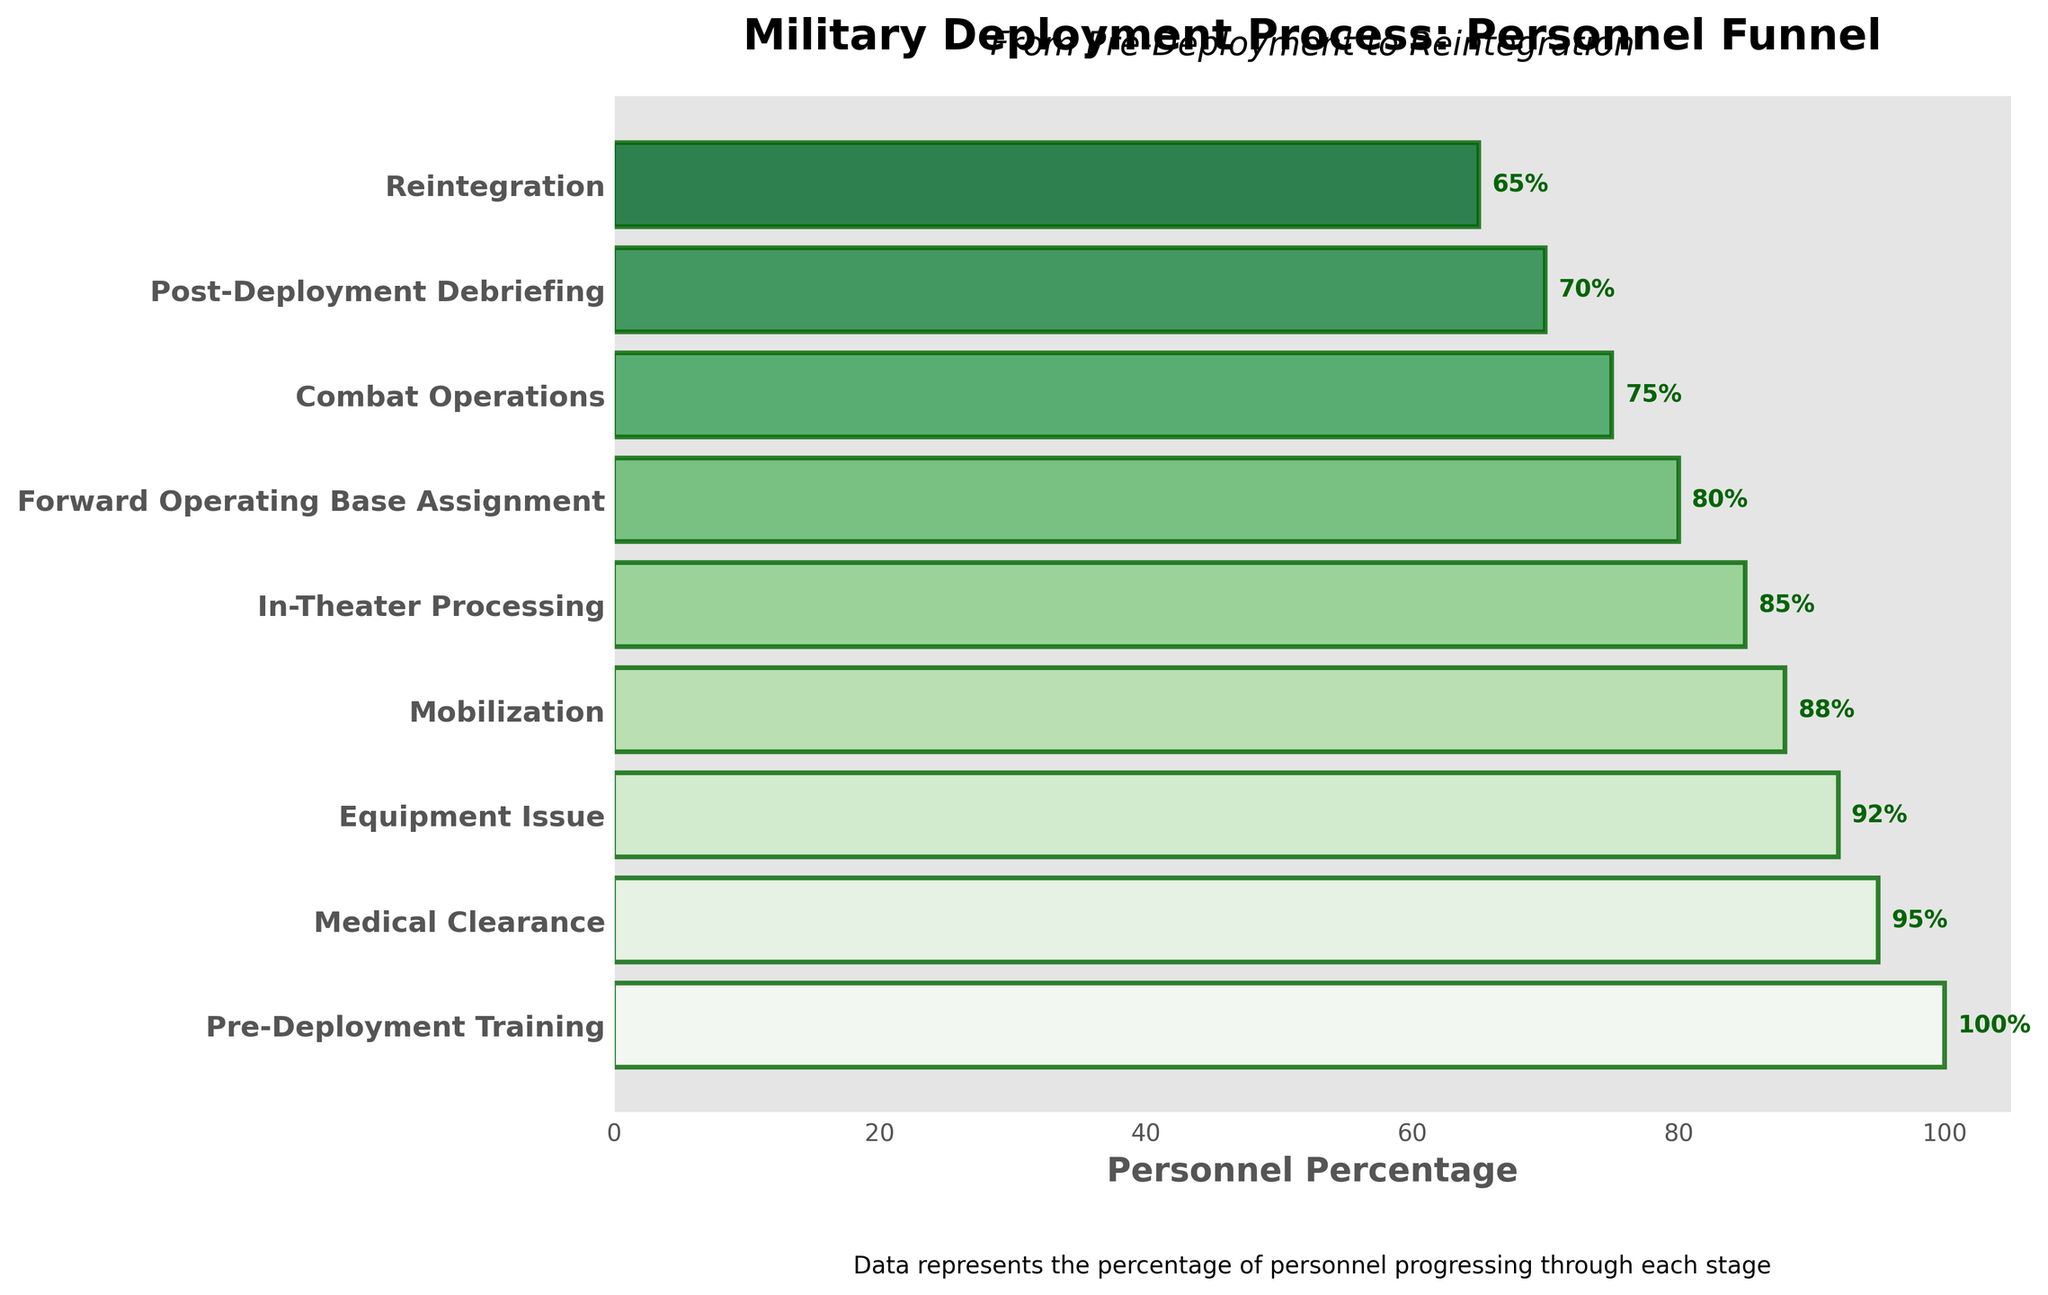What is the title of the funnel chart? The title of the funnel chart is prominently displayed at the top. It reads "Military Deployment Process: Personnel Funnel".
Answer: "Military Deployment Process: Personnel Funnel" What stage has the highest percentage of personnel? The highest percentage of personnel is displayed at the top of the funnel chart. It is labeled "Pre-Deployment Training" with a percentage of 100%.
Answer: Pre-Deployment Training How many stages are represented in the chart? The chart has labeled stages on the Y-axis. Counting these labels gives the number of stages shown in the funnel chart.
Answer: 9 What is the difference in personnel percentage between "Pre-Deployment Training" and "Reintegration"? Subtract the percentage of "Reintegration" from "Pre-Deployment Training". This is 100% - 65%.
Answer: 35% Which stage has a higher percentage of personnel, "Mobilization" or "Equipment Issue"? Compare the percentages next to the stage labels "Mobilization" (88%) and "Equipment Issue" (92%).
Answer: Equipment Issue What percentage of personnel make it to the "Forward Operating Base Assignment" stage? The funnel bar corresponding to the "Forward Operating Base Assignment" stage shows the percentage directly next to it.
Answer: 80% What is the average percentage of personnel for the stages "Medical Clearance", "Equipment Issue", and "Mobilization"? Sum the percentages of these stages and divide by the number of stages: (95% + 92% + 88%) / 3 = 275 / 3.
Answer: 91.67% Are there more personnel in the "In-Theater Processing" stage or in the "Post-Deployment Debriefing" stage? Compare the percentages next to the labels "In-Theater Processing" (85%) and "Post-Deployment Debriefing" (70%).
Answer: In-Theater Processing What trend is observed in the personnel percentages from "Pre-Deployment Training" to "Reintegration"? The trend can be identified by noting the percentages from each stage, observing that each subsequent stage has a lower percentage than the previous one, indicating a decreasing trend.
Answer: Decreasing trend 